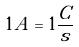<formula> <loc_0><loc_0><loc_500><loc_500>1 A = 1 \frac { C } { s }</formula> 